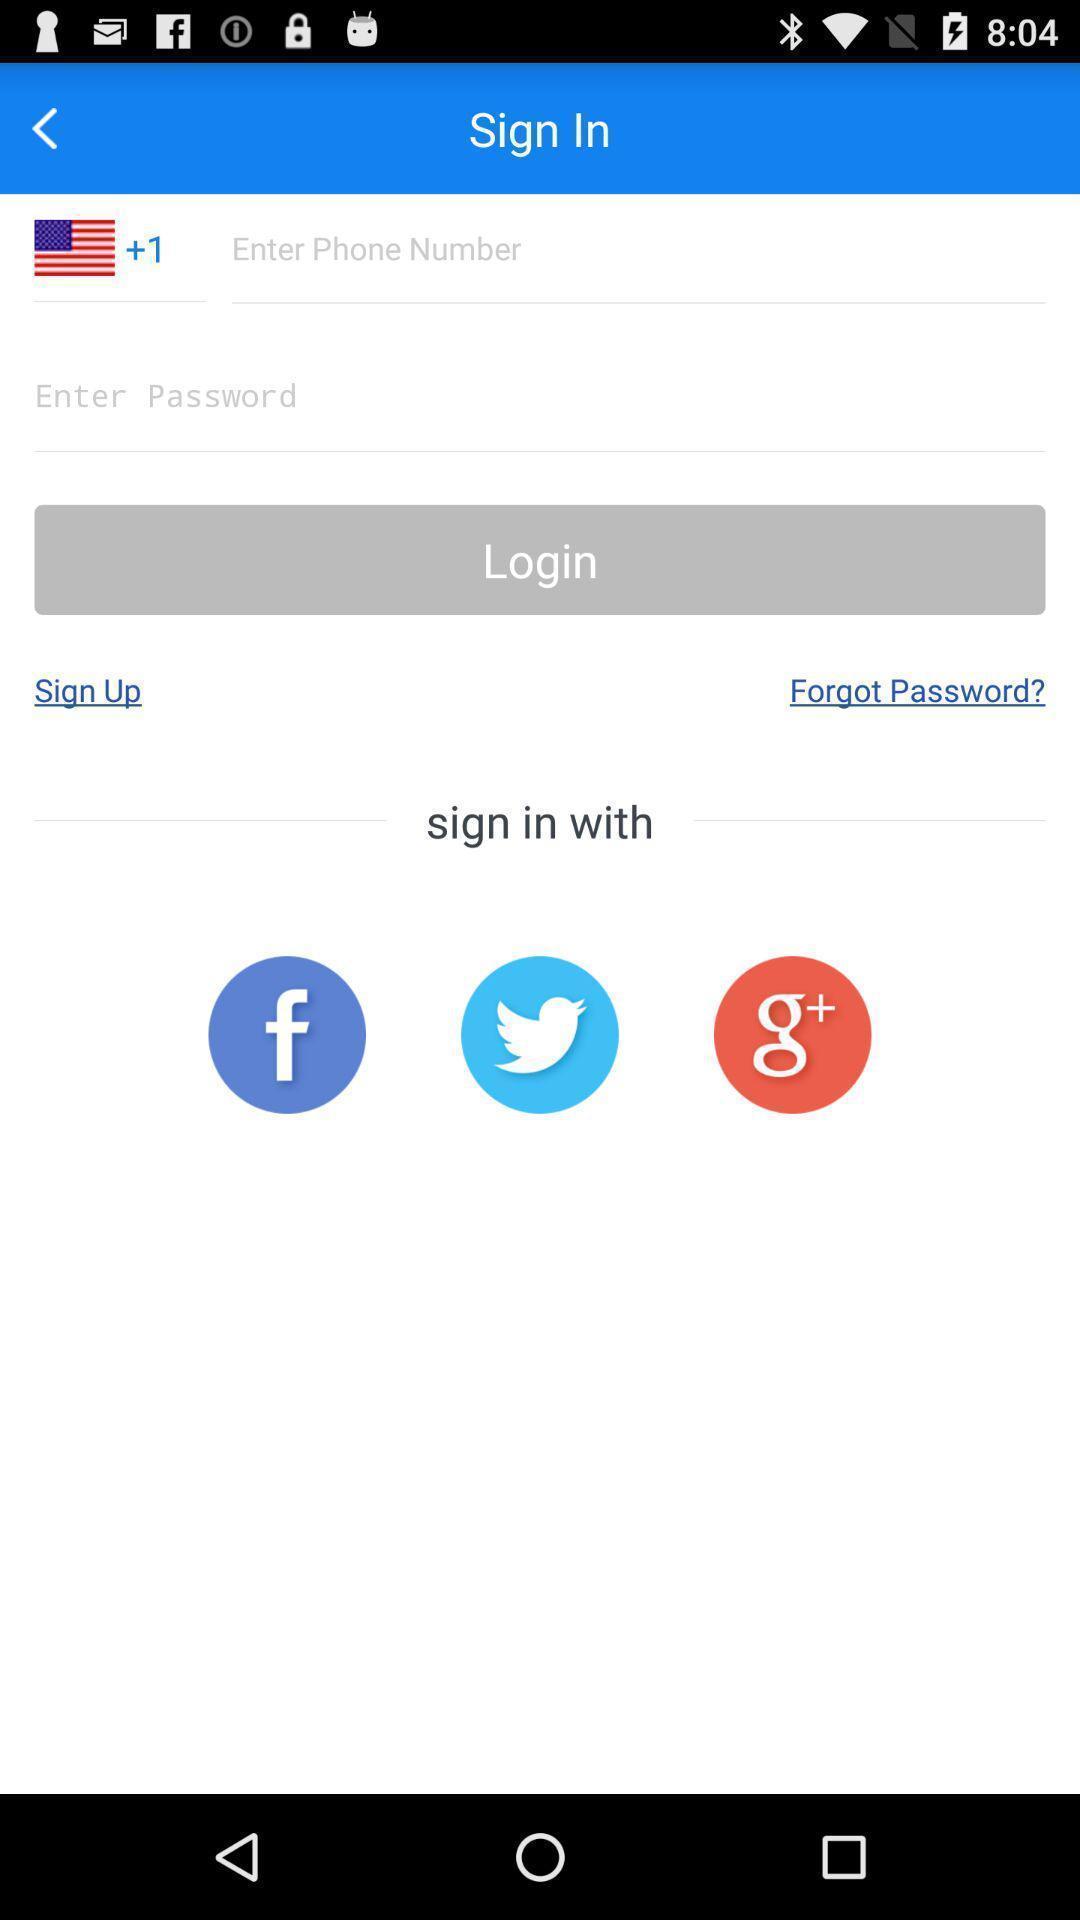Tell me about the visual elements in this screen capture. Sign in page displayed. 